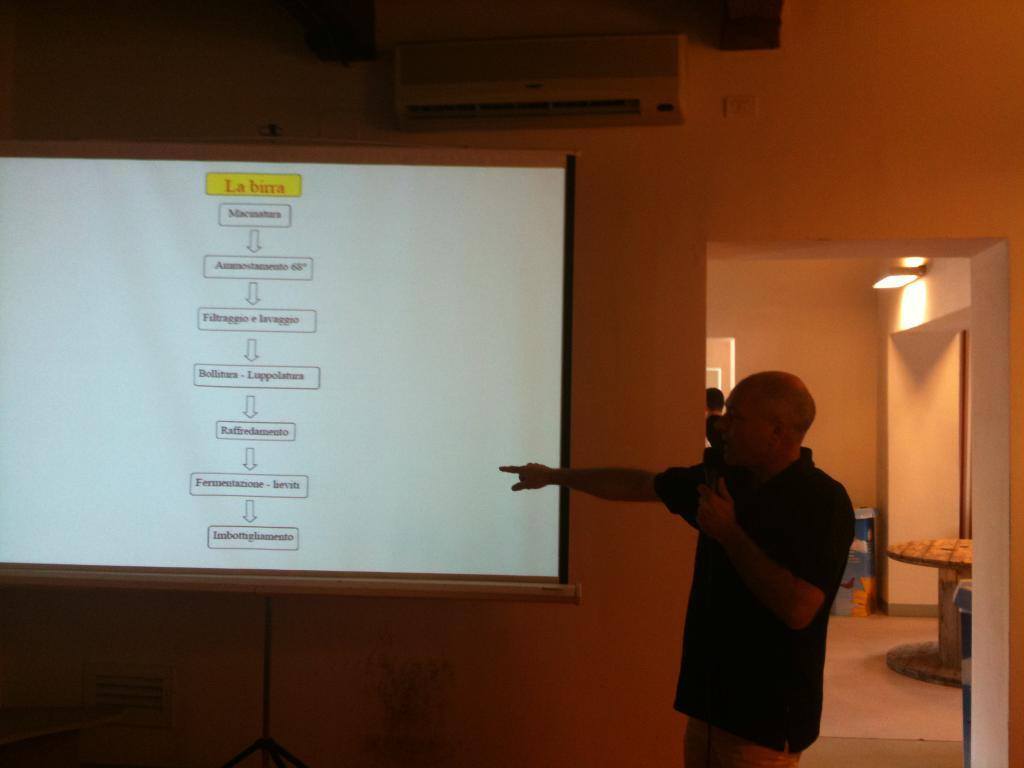<image>
Render a clear and concise summary of the photo. Professor giving a lecture in front of a projection screen on "La birra" with a flow chart underneath the title. 